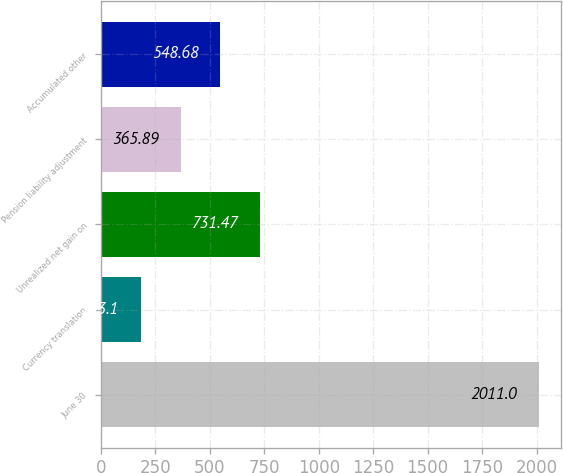Convert chart. <chart><loc_0><loc_0><loc_500><loc_500><bar_chart><fcel>June 30<fcel>Currency translation<fcel>Unrealized net gain on<fcel>Pension liability adjustment<fcel>Accumulated other<nl><fcel>2011<fcel>183.1<fcel>731.47<fcel>365.89<fcel>548.68<nl></chart> 